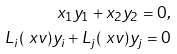Convert formula to latex. <formula><loc_0><loc_0><loc_500><loc_500>x _ { 1 } y _ { 1 } + x _ { 2 } y _ { 2 } = 0 , \\ L _ { i } ( \ x v ) y _ { i } + L _ { j } ( \ x v ) y _ { j } = 0</formula> 